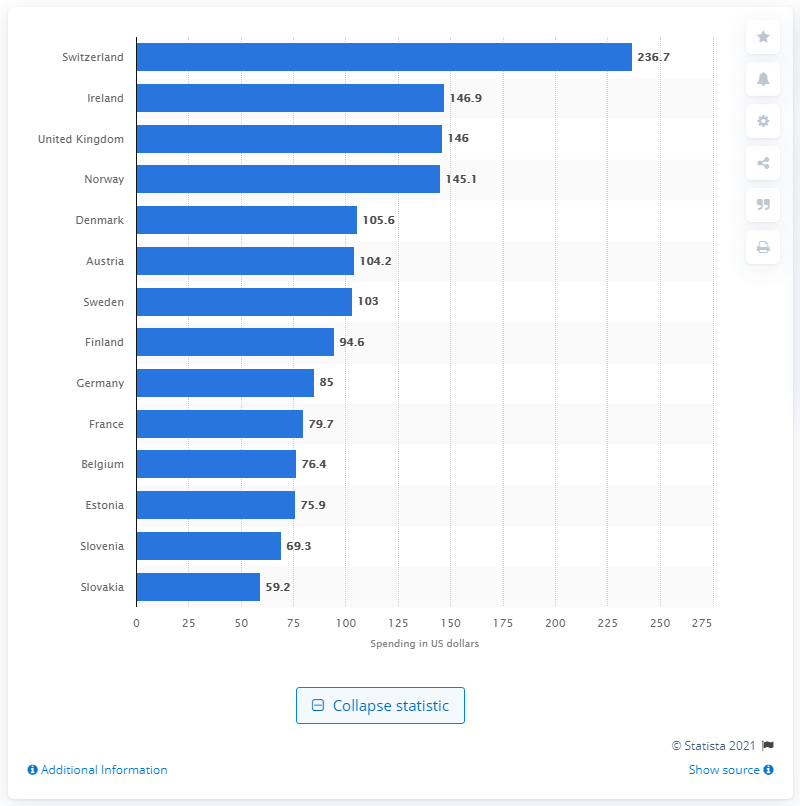Indicate a few pertinent items in this graphic. In 2015, Ireland had the highest per capita spending on chocolate among all countries, as reported. 